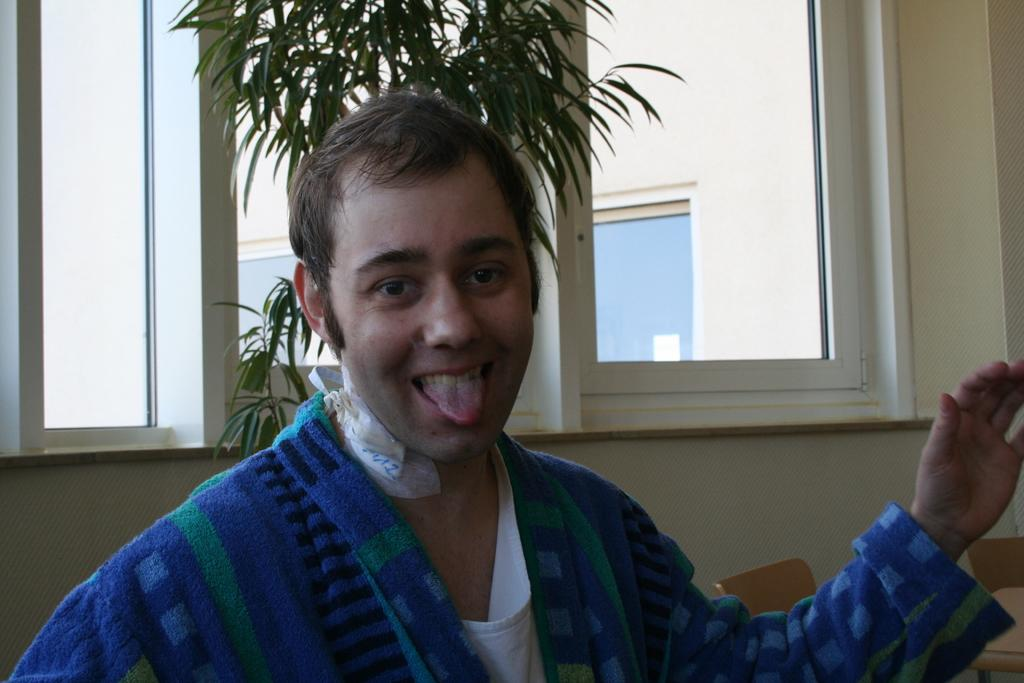What is the person in the image wearing? The person in the image is wearing a blue color jacket. What can be seen in the background of the image? There is a wall, a window, and a plant in the background of the image. How many snails can be seen crawling on the person's jacket in the image? There are no snails visible on the person's jacket in the image. What type of planes are flying in the background of the image? There are no planes visible in the background of the image. 